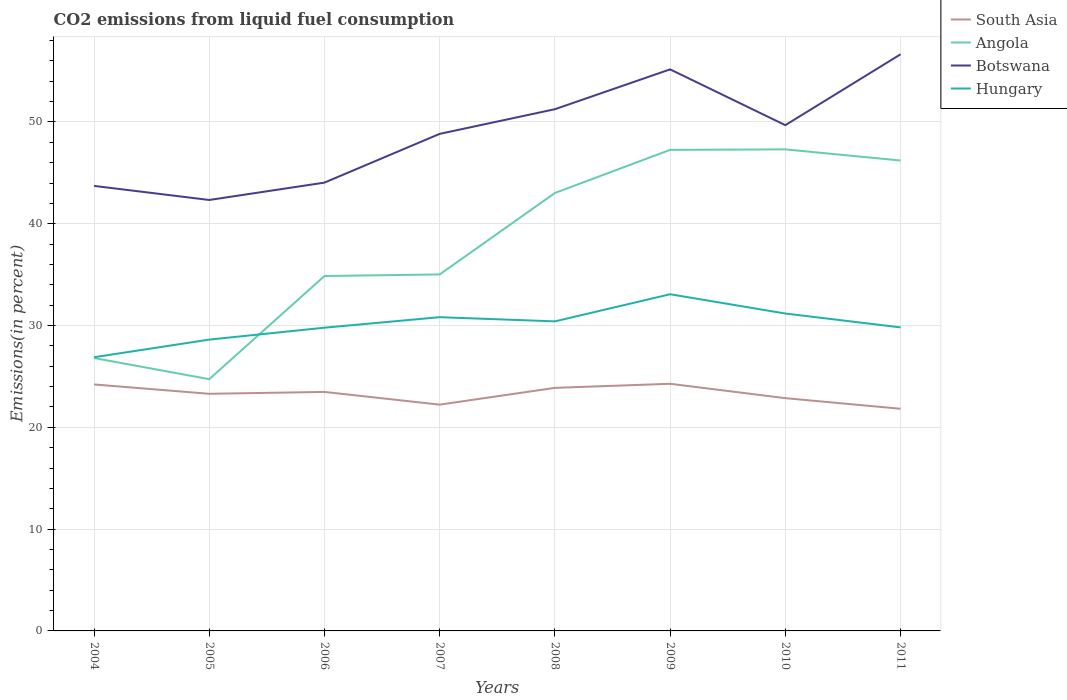How many different coloured lines are there?
Provide a succinct answer. 4. Across all years, what is the maximum total CO2 emitted in Angola?
Ensure brevity in your answer.  24.73. In which year was the total CO2 emitted in Angola maximum?
Keep it short and to the point. 2005. What is the total total CO2 emitted in South Asia in the graph?
Your response must be concise. -0.18. What is the difference between the highest and the second highest total CO2 emitted in South Asia?
Provide a short and direct response. 2.45. What is the difference between the highest and the lowest total CO2 emitted in Angola?
Offer a terse response. 4. How many lines are there?
Provide a short and direct response. 4. How many years are there in the graph?
Your response must be concise. 8. What is the difference between two consecutive major ticks on the Y-axis?
Provide a short and direct response. 10. Does the graph contain grids?
Keep it short and to the point. Yes. How are the legend labels stacked?
Provide a short and direct response. Vertical. What is the title of the graph?
Ensure brevity in your answer.  CO2 emissions from liquid fuel consumption. Does "Guam" appear as one of the legend labels in the graph?
Provide a succinct answer. No. What is the label or title of the X-axis?
Offer a very short reply. Years. What is the label or title of the Y-axis?
Your response must be concise. Emissions(in percent). What is the Emissions(in percent) in South Asia in 2004?
Give a very brief answer. 24.21. What is the Emissions(in percent) of Angola in 2004?
Offer a terse response. 26.81. What is the Emissions(in percent) in Botswana in 2004?
Make the answer very short. 43.72. What is the Emissions(in percent) in Hungary in 2004?
Your response must be concise. 26.89. What is the Emissions(in percent) of South Asia in 2005?
Provide a short and direct response. 23.29. What is the Emissions(in percent) of Angola in 2005?
Make the answer very short. 24.73. What is the Emissions(in percent) in Botswana in 2005?
Offer a very short reply. 42.34. What is the Emissions(in percent) of Hungary in 2005?
Keep it short and to the point. 28.62. What is the Emissions(in percent) in South Asia in 2006?
Keep it short and to the point. 23.48. What is the Emissions(in percent) of Angola in 2006?
Give a very brief answer. 34.86. What is the Emissions(in percent) in Botswana in 2006?
Provide a succinct answer. 44.04. What is the Emissions(in percent) in Hungary in 2006?
Your answer should be compact. 29.79. What is the Emissions(in percent) of South Asia in 2007?
Your answer should be very brief. 22.23. What is the Emissions(in percent) of Angola in 2007?
Offer a terse response. 35.02. What is the Emissions(in percent) of Botswana in 2007?
Your answer should be compact. 48.83. What is the Emissions(in percent) in Hungary in 2007?
Give a very brief answer. 30.82. What is the Emissions(in percent) of South Asia in 2008?
Offer a terse response. 23.88. What is the Emissions(in percent) of Angola in 2008?
Give a very brief answer. 43.02. What is the Emissions(in percent) in Botswana in 2008?
Offer a terse response. 51.25. What is the Emissions(in percent) in Hungary in 2008?
Ensure brevity in your answer.  30.41. What is the Emissions(in percent) of South Asia in 2009?
Offer a very short reply. 24.28. What is the Emissions(in percent) in Angola in 2009?
Offer a terse response. 47.26. What is the Emissions(in percent) of Botswana in 2009?
Your answer should be very brief. 55.17. What is the Emissions(in percent) of Hungary in 2009?
Your answer should be compact. 33.08. What is the Emissions(in percent) of South Asia in 2010?
Your answer should be very brief. 22.87. What is the Emissions(in percent) in Angola in 2010?
Keep it short and to the point. 47.31. What is the Emissions(in percent) of Botswana in 2010?
Offer a very short reply. 49.68. What is the Emissions(in percent) of Hungary in 2010?
Ensure brevity in your answer.  31.18. What is the Emissions(in percent) of South Asia in 2011?
Keep it short and to the point. 21.82. What is the Emissions(in percent) of Angola in 2011?
Ensure brevity in your answer.  46.21. What is the Emissions(in percent) of Botswana in 2011?
Your answer should be compact. 56.65. What is the Emissions(in percent) in Hungary in 2011?
Your answer should be very brief. 29.82. Across all years, what is the maximum Emissions(in percent) of South Asia?
Offer a terse response. 24.28. Across all years, what is the maximum Emissions(in percent) of Angola?
Offer a very short reply. 47.31. Across all years, what is the maximum Emissions(in percent) of Botswana?
Offer a very short reply. 56.65. Across all years, what is the maximum Emissions(in percent) of Hungary?
Provide a short and direct response. 33.08. Across all years, what is the minimum Emissions(in percent) of South Asia?
Provide a short and direct response. 21.82. Across all years, what is the minimum Emissions(in percent) of Angola?
Make the answer very short. 24.73. Across all years, what is the minimum Emissions(in percent) in Botswana?
Make the answer very short. 42.34. Across all years, what is the minimum Emissions(in percent) of Hungary?
Make the answer very short. 26.89. What is the total Emissions(in percent) in South Asia in the graph?
Offer a very short reply. 186.06. What is the total Emissions(in percent) in Angola in the graph?
Offer a very short reply. 305.22. What is the total Emissions(in percent) of Botswana in the graph?
Offer a terse response. 391.67. What is the total Emissions(in percent) in Hungary in the graph?
Give a very brief answer. 240.6. What is the difference between the Emissions(in percent) of South Asia in 2004 and that in 2005?
Keep it short and to the point. 0.92. What is the difference between the Emissions(in percent) of Angola in 2004 and that in 2005?
Your response must be concise. 2.08. What is the difference between the Emissions(in percent) in Botswana in 2004 and that in 2005?
Provide a succinct answer. 1.38. What is the difference between the Emissions(in percent) of Hungary in 2004 and that in 2005?
Offer a terse response. -1.73. What is the difference between the Emissions(in percent) of South Asia in 2004 and that in 2006?
Your answer should be very brief. 0.73. What is the difference between the Emissions(in percent) in Angola in 2004 and that in 2006?
Make the answer very short. -8.06. What is the difference between the Emissions(in percent) of Botswana in 2004 and that in 2006?
Offer a terse response. -0.32. What is the difference between the Emissions(in percent) in Hungary in 2004 and that in 2006?
Offer a terse response. -2.9. What is the difference between the Emissions(in percent) in South Asia in 2004 and that in 2007?
Provide a succinct answer. 1.98. What is the difference between the Emissions(in percent) in Angola in 2004 and that in 2007?
Your answer should be compact. -8.21. What is the difference between the Emissions(in percent) in Botswana in 2004 and that in 2007?
Give a very brief answer. -5.11. What is the difference between the Emissions(in percent) of Hungary in 2004 and that in 2007?
Your response must be concise. -3.94. What is the difference between the Emissions(in percent) of South Asia in 2004 and that in 2008?
Your answer should be very brief. 0.34. What is the difference between the Emissions(in percent) of Angola in 2004 and that in 2008?
Your answer should be very brief. -16.21. What is the difference between the Emissions(in percent) in Botswana in 2004 and that in 2008?
Provide a short and direct response. -7.53. What is the difference between the Emissions(in percent) of Hungary in 2004 and that in 2008?
Give a very brief answer. -3.52. What is the difference between the Emissions(in percent) of South Asia in 2004 and that in 2009?
Provide a succinct answer. -0.07. What is the difference between the Emissions(in percent) in Angola in 2004 and that in 2009?
Your answer should be very brief. -20.45. What is the difference between the Emissions(in percent) in Botswana in 2004 and that in 2009?
Keep it short and to the point. -11.45. What is the difference between the Emissions(in percent) in Hungary in 2004 and that in 2009?
Provide a succinct answer. -6.19. What is the difference between the Emissions(in percent) in South Asia in 2004 and that in 2010?
Offer a very short reply. 1.35. What is the difference between the Emissions(in percent) of Angola in 2004 and that in 2010?
Keep it short and to the point. -20.5. What is the difference between the Emissions(in percent) of Botswana in 2004 and that in 2010?
Give a very brief answer. -5.97. What is the difference between the Emissions(in percent) of Hungary in 2004 and that in 2010?
Your answer should be very brief. -4.29. What is the difference between the Emissions(in percent) in South Asia in 2004 and that in 2011?
Give a very brief answer. 2.39. What is the difference between the Emissions(in percent) in Angola in 2004 and that in 2011?
Offer a terse response. -19.4. What is the difference between the Emissions(in percent) in Botswana in 2004 and that in 2011?
Your answer should be very brief. -12.93. What is the difference between the Emissions(in percent) of Hungary in 2004 and that in 2011?
Your response must be concise. -2.93. What is the difference between the Emissions(in percent) in South Asia in 2005 and that in 2006?
Keep it short and to the point. -0.18. What is the difference between the Emissions(in percent) in Angola in 2005 and that in 2006?
Give a very brief answer. -10.13. What is the difference between the Emissions(in percent) of Botswana in 2005 and that in 2006?
Keep it short and to the point. -1.71. What is the difference between the Emissions(in percent) in Hungary in 2005 and that in 2006?
Provide a short and direct response. -1.17. What is the difference between the Emissions(in percent) in South Asia in 2005 and that in 2007?
Your response must be concise. 1.06. What is the difference between the Emissions(in percent) of Angola in 2005 and that in 2007?
Make the answer very short. -10.29. What is the difference between the Emissions(in percent) of Botswana in 2005 and that in 2007?
Offer a terse response. -6.49. What is the difference between the Emissions(in percent) in Hungary in 2005 and that in 2007?
Provide a short and direct response. -2.2. What is the difference between the Emissions(in percent) of South Asia in 2005 and that in 2008?
Offer a terse response. -0.58. What is the difference between the Emissions(in percent) of Angola in 2005 and that in 2008?
Provide a short and direct response. -18.29. What is the difference between the Emissions(in percent) in Botswana in 2005 and that in 2008?
Give a very brief answer. -8.92. What is the difference between the Emissions(in percent) in Hungary in 2005 and that in 2008?
Provide a short and direct response. -1.79. What is the difference between the Emissions(in percent) of South Asia in 2005 and that in 2009?
Your answer should be very brief. -0.98. What is the difference between the Emissions(in percent) in Angola in 2005 and that in 2009?
Provide a short and direct response. -22.53. What is the difference between the Emissions(in percent) in Botswana in 2005 and that in 2009?
Offer a terse response. -12.83. What is the difference between the Emissions(in percent) in Hungary in 2005 and that in 2009?
Your answer should be very brief. -4.46. What is the difference between the Emissions(in percent) in South Asia in 2005 and that in 2010?
Your answer should be compact. 0.43. What is the difference between the Emissions(in percent) in Angola in 2005 and that in 2010?
Offer a terse response. -22.57. What is the difference between the Emissions(in percent) in Botswana in 2005 and that in 2010?
Provide a short and direct response. -7.35. What is the difference between the Emissions(in percent) in Hungary in 2005 and that in 2010?
Ensure brevity in your answer.  -2.56. What is the difference between the Emissions(in percent) of South Asia in 2005 and that in 2011?
Your answer should be compact. 1.47. What is the difference between the Emissions(in percent) of Angola in 2005 and that in 2011?
Give a very brief answer. -21.48. What is the difference between the Emissions(in percent) in Botswana in 2005 and that in 2011?
Provide a succinct answer. -14.31. What is the difference between the Emissions(in percent) of Hungary in 2005 and that in 2011?
Provide a succinct answer. -1.2. What is the difference between the Emissions(in percent) of South Asia in 2006 and that in 2007?
Make the answer very short. 1.25. What is the difference between the Emissions(in percent) in Angola in 2006 and that in 2007?
Ensure brevity in your answer.  -0.15. What is the difference between the Emissions(in percent) of Botswana in 2006 and that in 2007?
Make the answer very short. -4.79. What is the difference between the Emissions(in percent) of Hungary in 2006 and that in 2007?
Make the answer very short. -1.03. What is the difference between the Emissions(in percent) of South Asia in 2006 and that in 2008?
Your response must be concise. -0.4. What is the difference between the Emissions(in percent) of Angola in 2006 and that in 2008?
Make the answer very short. -8.16. What is the difference between the Emissions(in percent) in Botswana in 2006 and that in 2008?
Keep it short and to the point. -7.21. What is the difference between the Emissions(in percent) in Hungary in 2006 and that in 2008?
Ensure brevity in your answer.  -0.62. What is the difference between the Emissions(in percent) of South Asia in 2006 and that in 2009?
Your answer should be compact. -0.8. What is the difference between the Emissions(in percent) in Angola in 2006 and that in 2009?
Offer a very short reply. -12.39. What is the difference between the Emissions(in percent) of Botswana in 2006 and that in 2009?
Ensure brevity in your answer.  -11.13. What is the difference between the Emissions(in percent) in Hungary in 2006 and that in 2009?
Offer a very short reply. -3.29. What is the difference between the Emissions(in percent) of South Asia in 2006 and that in 2010?
Keep it short and to the point. 0.61. What is the difference between the Emissions(in percent) in Angola in 2006 and that in 2010?
Your answer should be compact. -12.44. What is the difference between the Emissions(in percent) in Botswana in 2006 and that in 2010?
Make the answer very short. -5.64. What is the difference between the Emissions(in percent) in Hungary in 2006 and that in 2010?
Your answer should be very brief. -1.39. What is the difference between the Emissions(in percent) in South Asia in 2006 and that in 2011?
Keep it short and to the point. 1.65. What is the difference between the Emissions(in percent) of Angola in 2006 and that in 2011?
Make the answer very short. -11.35. What is the difference between the Emissions(in percent) of Botswana in 2006 and that in 2011?
Your answer should be very brief. -12.61. What is the difference between the Emissions(in percent) of Hungary in 2006 and that in 2011?
Your answer should be compact. -0.03. What is the difference between the Emissions(in percent) of South Asia in 2007 and that in 2008?
Provide a succinct answer. -1.65. What is the difference between the Emissions(in percent) in Angola in 2007 and that in 2008?
Offer a very short reply. -8. What is the difference between the Emissions(in percent) of Botswana in 2007 and that in 2008?
Provide a short and direct response. -2.42. What is the difference between the Emissions(in percent) in Hungary in 2007 and that in 2008?
Provide a short and direct response. 0.41. What is the difference between the Emissions(in percent) in South Asia in 2007 and that in 2009?
Provide a short and direct response. -2.05. What is the difference between the Emissions(in percent) of Angola in 2007 and that in 2009?
Ensure brevity in your answer.  -12.24. What is the difference between the Emissions(in percent) of Botswana in 2007 and that in 2009?
Make the answer very short. -6.34. What is the difference between the Emissions(in percent) of Hungary in 2007 and that in 2009?
Give a very brief answer. -2.25. What is the difference between the Emissions(in percent) of South Asia in 2007 and that in 2010?
Your response must be concise. -0.64. What is the difference between the Emissions(in percent) in Angola in 2007 and that in 2010?
Offer a terse response. -12.29. What is the difference between the Emissions(in percent) in Botswana in 2007 and that in 2010?
Your answer should be compact. -0.85. What is the difference between the Emissions(in percent) of Hungary in 2007 and that in 2010?
Make the answer very short. -0.36. What is the difference between the Emissions(in percent) of South Asia in 2007 and that in 2011?
Provide a short and direct response. 0.41. What is the difference between the Emissions(in percent) of Angola in 2007 and that in 2011?
Your answer should be compact. -11.19. What is the difference between the Emissions(in percent) in Botswana in 2007 and that in 2011?
Provide a short and direct response. -7.82. What is the difference between the Emissions(in percent) in Hungary in 2007 and that in 2011?
Give a very brief answer. 1.01. What is the difference between the Emissions(in percent) of South Asia in 2008 and that in 2009?
Your answer should be very brief. -0.4. What is the difference between the Emissions(in percent) of Angola in 2008 and that in 2009?
Offer a terse response. -4.24. What is the difference between the Emissions(in percent) in Botswana in 2008 and that in 2009?
Keep it short and to the point. -3.91. What is the difference between the Emissions(in percent) of Hungary in 2008 and that in 2009?
Ensure brevity in your answer.  -2.67. What is the difference between the Emissions(in percent) in South Asia in 2008 and that in 2010?
Provide a succinct answer. 1.01. What is the difference between the Emissions(in percent) in Angola in 2008 and that in 2010?
Your answer should be compact. -4.28. What is the difference between the Emissions(in percent) of Botswana in 2008 and that in 2010?
Your answer should be compact. 1.57. What is the difference between the Emissions(in percent) of Hungary in 2008 and that in 2010?
Your answer should be very brief. -0.77. What is the difference between the Emissions(in percent) in South Asia in 2008 and that in 2011?
Your answer should be very brief. 2.05. What is the difference between the Emissions(in percent) in Angola in 2008 and that in 2011?
Your response must be concise. -3.19. What is the difference between the Emissions(in percent) in Botswana in 2008 and that in 2011?
Ensure brevity in your answer.  -5.39. What is the difference between the Emissions(in percent) in Hungary in 2008 and that in 2011?
Provide a short and direct response. 0.59. What is the difference between the Emissions(in percent) of South Asia in 2009 and that in 2010?
Offer a terse response. 1.41. What is the difference between the Emissions(in percent) in Angola in 2009 and that in 2010?
Give a very brief answer. -0.05. What is the difference between the Emissions(in percent) in Botswana in 2009 and that in 2010?
Provide a succinct answer. 5.48. What is the difference between the Emissions(in percent) in Hungary in 2009 and that in 2010?
Make the answer very short. 1.9. What is the difference between the Emissions(in percent) of South Asia in 2009 and that in 2011?
Give a very brief answer. 2.45. What is the difference between the Emissions(in percent) of Angola in 2009 and that in 2011?
Keep it short and to the point. 1.05. What is the difference between the Emissions(in percent) in Botswana in 2009 and that in 2011?
Ensure brevity in your answer.  -1.48. What is the difference between the Emissions(in percent) in Hungary in 2009 and that in 2011?
Keep it short and to the point. 3.26. What is the difference between the Emissions(in percent) in South Asia in 2010 and that in 2011?
Offer a very short reply. 1.04. What is the difference between the Emissions(in percent) in Angola in 2010 and that in 2011?
Your answer should be very brief. 1.1. What is the difference between the Emissions(in percent) in Botswana in 2010 and that in 2011?
Ensure brevity in your answer.  -6.96. What is the difference between the Emissions(in percent) in Hungary in 2010 and that in 2011?
Offer a very short reply. 1.36. What is the difference between the Emissions(in percent) of South Asia in 2004 and the Emissions(in percent) of Angola in 2005?
Your answer should be very brief. -0.52. What is the difference between the Emissions(in percent) in South Asia in 2004 and the Emissions(in percent) in Botswana in 2005?
Give a very brief answer. -18.12. What is the difference between the Emissions(in percent) of South Asia in 2004 and the Emissions(in percent) of Hungary in 2005?
Provide a succinct answer. -4.41. What is the difference between the Emissions(in percent) in Angola in 2004 and the Emissions(in percent) in Botswana in 2005?
Give a very brief answer. -15.53. What is the difference between the Emissions(in percent) of Angola in 2004 and the Emissions(in percent) of Hungary in 2005?
Provide a short and direct response. -1.81. What is the difference between the Emissions(in percent) in Botswana in 2004 and the Emissions(in percent) in Hungary in 2005?
Offer a terse response. 15.1. What is the difference between the Emissions(in percent) of South Asia in 2004 and the Emissions(in percent) of Angola in 2006?
Offer a very short reply. -10.65. What is the difference between the Emissions(in percent) in South Asia in 2004 and the Emissions(in percent) in Botswana in 2006?
Make the answer very short. -19.83. What is the difference between the Emissions(in percent) of South Asia in 2004 and the Emissions(in percent) of Hungary in 2006?
Make the answer very short. -5.58. What is the difference between the Emissions(in percent) of Angola in 2004 and the Emissions(in percent) of Botswana in 2006?
Make the answer very short. -17.23. What is the difference between the Emissions(in percent) in Angola in 2004 and the Emissions(in percent) in Hungary in 2006?
Give a very brief answer. -2.98. What is the difference between the Emissions(in percent) in Botswana in 2004 and the Emissions(in percent) in Hungary in 2006?
Offer a very short reply. 13.93. What is the difference between the Emissions(in percent) of South Asia in 2004 and the Emissions(in percent) of Angola in 2007?
Provide a succinct answer. -10.81. What is the difference between the Emissions(in percent) of South Asia in 2004 and the Emissions(in percent) of Botswana in 2007?
Offer a very short reply. -24.62. What is the difference between the Emissions(in percent) of South Asia in 2004 and the Emissions(in percent) of Hungary in 2007?
Provide a succinct answer. -6.61. What is the difference between the Emissions(in percent) in Angola in 2004 and the Emissions(in percent) in Botswana in 2007?
Ensure brevity in your answer.  -22.02. What is the difference between the Emissions(in percent) of Angola in 2004 and the Emissions(in percent) of Hungary in 2007?
Provide a short and direct response. -4.01. What is the difference between the Emissions(in percent) in Botswana in 2004 and the Emissions(in percent) in Hungary in 2007?
Ensure brevity in your answer.  12.9. What is the difference between the Emissions(in percent) of South Asia in 2004 and the Emissions(in percent) of Angola in 2008?
Give a very brief answer. -18.81. What is the difference between the Emissions(in percent) of South Asia in 2004 and the Emissions(in percent) of Botswana in 2008?
Your answer should be compact. -27.04. What is the difference between the Emissions(in percent) of South Asia in 2004 and the Emissions(in percent) of Hungary in 2008?
Keep it short and to the point. -6.2. What is the difference between the Emissions(in percent) in Angola in 2004 and the Emissions(in percent) in Botswana in 2008?
Keep it short and to the point. -24.44. What is the difference between the Emissions(in percent) in Angola in 2004 and the Emissions(in percent) in Hungary in 2008?
Ensure brevity in your answer.  -3.6. What is the difference between the Emissions(in percent) in Botswana in 2004 and the Emissions(in percent) in Hungary in 2008?
Your answer should be compact. 13.31. What is the difference between the Emissions(in percent) of South Asia in 2004 and the Emissions(in percent) of Angola in 2009?
Keep it short and to the point. -23.05. What is the difference between the Emissions(in percent) of South Asia in 2004 and the Emissions(in percent) of Botswana in 2009?
Your answer should be very brief. -30.95. What is the difference between the Emissions(in percent) in South Asia in 2004 and the Emissions(in percent) in Hungary in 2009?
Your answer should be very brief. -8.86. What is the difference between the Emissions(in percent) in Angola in 2004 and the Emissions(in percent) in Botswana in 2009?
Give a very brief answer. -28.36. What is the difference between the Emissions(in percent) of Angola in 2004 and the Emissions(in percent) of Hungary in 2009?
Provide a succinct answer. -6.27. What is the difference between the Emissions(in percent) in Botswana in 2004 and the Emissions(in percent) in Hungary in 2009?
Your response must be concise. 10.64. What is the difference between the Emissions(in percent) in South Asia in 2004 and the Emissions(in percent) in Angola in 2010?
Offer a very short reply. -23.09. What is the difference between the Emissions(in percent) in South Asia in 2004 and the Emissions(in percent) in Botswana in 2010?
Give a very brief answer. -25.47. What is the difference between the Emissions(in percent) of South Asia in 2004 and the Emissions(in percent) of Hungary in 2010?
Offer a terse response. -6.97. What is the difference between the Emissions(in percent) in Angola in 2004 and the Emissions(in percent) in Botswana in 2010?
Give a very brief answer. -22.87. What is the difference between the Emissions(in percent) in Angola in 2004 and the Emissions(in percent) in Hungary in 2010?
Provide a short and direct response. -4.37. What is the difference between the Emissions(in percent) in Botswana in 2004 and the Emissions(in percent) in Hungary in 2010?
Provide a succinct answer. 12.54. What is the difference between the Emissions(in percent) in South Asia in 2004 and the Emissions(in percent) in Angola in 2011?
Give a very brief answer. -22. What is the difference between the Emissions(in percent) of South Asia in 2004 and the Emissions(in percent) of Botswana in 2011?
Offer a terse response. -32.43. What is the difference between the Emissions(in percent) in South Asia in 2004 and the Emissions(in percent) in Hungary in 2011?
Your answer should be very brief. -5.6. What is the difference between the Emissions(in percent) in Angola in 2004 and the Emissions(in percent) in Botswana in 2011?
Your response must be concise. -29.84. What is the difference between the Emissions(in percent) in Angola in 2004 and the Emissions(in percent) in Hungary in 2011?
Offer a very short reply. -3.01. What is the difference between the Emissions(in percent) in Botswana in 2004 and the Emissions(in percent) in Hungary in 2011?
Give a very brief answer. 13.9. What is the difference between the Emissions(in percent) of South Asia in 2005 and the Emissions(in percent) of Angola in 2006?
Your response must be concise. -11.57. What is the difference between the Emissions(in percent) of South Asia in 2005 and the Emissions(in percent) of Botswana in 2006?
Make the answer very short. -20.75. What is the difference between the Emissions(in percent) in South Asia in 2005 and the Emissions(in percent) in Hungary in 2006?
Ensure brevity in your answer.  -6.49. What is the difference between the Emissions(in percent) in Angola in 2005 and the Emissions(in percent) in Botswana in 2006?
Provide a short and direct response. -19.31. What is the difference between the Emissions(in percent) of Angola in 2005 and the Emissions(in percent) of Hungary in 2006?
Keep it short and to the point. -5.06. What is the difference between the Emissions(in percent) of Botswana in 2005 and the Emissions(in percent) of Hungary in 2006?
Ensure brevity in your answer.  12.55. What is the difference between the Emissions(in percent) of South Asia in 2005 and the Emissions(in percent) of Angola in 2007?
Your response must be concise. -11.73. What is the difference between the Emissions(in percent) of South Asia in 2005 and the Emissions(in percent) of Botswana in 2007?
Provide a short and direct response. -25.54. What is the difference between the Emissions(in percent) of South Asia in 2005 and the Emissions(in percent) of Hungary in 2007?
Provide a short and direct response. -7.53. What is the difference between the Emissions(in percent) in Angola in 2005 and the Emissions(in percent) in Botswana in 2007?
Offer a terse response. -24.1. What is the difference between the Emissions(in percent) in Angola in 2005 and the Emissions(in percent) in Hungary in 2007?
Your response must be concise. -6.09. What is the difference between the Emissions(in percent) of Botswana in 2005 and the Emissions(in percent) of Hungary in 2007?
Provide a succinct answer. 11.51. What is the difference between the Emissions(in percent) of South Asia in 2005 and the Emissions(in percent) of Angola in 2008?
Offer a very short reply. -19.73. What is the difference between the Emissions(in percent) of South Asia in 2005 and the Emissions(in percent) of Botswana in 2008?
Offer a very short reply. -27.96. What is the difference between the Emissions(in percent) of South Asia in 2005 and the Emissions(in percent) of Hungary in 2008?
Your response must be concise. -7.12. What is the difference between the Emissions(in percent) in Angola in 2005 and the Emissions(in percent) in Botswana in 2008?
Offer a terse response. -26.52. What is the difference between the Emissions(in percent) of Angola in 2005 and the Emissions(in percent) of Hungary in 2008?
Provide a succinct answer. -5.68. What is the difference between the Emissions(in percent) in Botswana in 2005 and the Emissions(in percent) in Hungary in 2008?
Ensure brevity in your answer.  11.93. What is the difference between the Emissions(in percent) of South Asia in 2005 and the Emissions(in percent) of Angola in 2009?
Give a very brief answer. -23.96. What is the difference between the Emissions(in percent) of South Asia in 2005 and the Emissions(in percent) of Botswana in 2009?
Ensure brevity in your answer.  -31.87. What is the difference between the Emissions(in percent) of South Asia in 2005 and the Emissions(in percent) of Hungary in 2009?
Make the answer very short. -9.78. What is the difference between the Emissions(in percent) of Angola in 2005 and the Emissions(in percent) of Botswana in 2009?
Provide a short and direct response. -30.43. What is the difference between the Emissions(in percent) of Angola in 2005 and the Emissions(in percent) of Hungary in 2009?
Offer a terse response. -8.34. What is the difference between the Emissions(in percent) of Botswana in 2005 and the Emissions(in percent) of Hungary in 2009?
Offer a very short reply. 9.26. What is the difference between the Emissions(in percent) of South Asia in 2005 and the Emissions(in percent) of Angola in 2010?
Keep it short and to the point. -24.01. What is the difference between the Emissions(in percent) of South Asia in 2005 and the Emissions(in percent) of Botswana in 2010?
Your response must be concise. -26.39. What is the difference between the Emissions(in percent) of South Asia in 2005 and the Emissions(in percent) of Hungary in 2010?
Provide a short and direct response. -7.89. What is the difference between the Emissions(in percent) in Angola in 2005 and the Emissions(in percent) in Botswana in 2010?
Your response must be concise. -24.95. What is the difference between the Emissions(in percent) of Angola in 2005 and the Emissions(in percent) of Hungary in 2010?
Give a very brief answer. -6.45. What is the difference between the Emissions(in percent) of Botswana in 2005 and the Emissions(in percent) of Hungary in 2010?
Your response must be concise. 11.16. What is the difference between the Emissions(in percent) in South Asia in 2005 and the Emissions(in percent) in Angola in 2011?
Your answer should be compact. -22.92. What is the difference between the Emissions(in percent) of South Asia in 2005 and the Emissions(in percent) of Botswana in 2011?
Your response must be concise. -33.35. What is the difference between the Emissions(in percent) of South Asia in 2005 and the Emissions(in percent) of Hungary in 2011?
Provide a short and direct response. -6.52. What is the difference between the Emissions(in percent) in Angola in 2005 and the Emissions(in percent) in Botswana in 2011?
Make the answer very short. -31.91. What is the difference between the Emissions(in percent) in Angola in 2005 and the Emissions(in percent) in Hungary in 2011?
Provide a succinct answer. -5.08. What is the difference between the Emissions(in percent) of Botswana in 2005 and the Emissions(in percent) of Hungary in 2011?
Your answer should be compact. 12.52. What is the difference between the Emissions(in percent) in South Asia in 2006 and the Emissions(in percent) in Angola in 2007?
Your response must be concise. -11.54. What is the difference between the Emissions(in percent) of South Asia in 2006 and the Emissions(in percent) of Botswana in 2007?
Your answer should be very brief. -25.35. What is the difference between the Emissions(in percent) in South Asia in 2006 and the Emissions(in percent) in Hungary in 2007?
Offer a terse response. -7.34. What is the difference between the Emissions(in percent) in Angola in 2006 and the Emissions(in percent) in Botswana in 2007?
Your answer should be very brief. -13.96. What is the difference between the Emissions(in percent) in Angola in 2006 and the Emissions(in percent) in Hungary in 2007?
Give a very brief answer. 4.04. What is the difference between the Emissions(in percent) in Botswana in 2006 and the Emissions(in percent) in Hungary in 2007?
Provide a short and direct response. 13.22. What is the difference between the Emissions(in percent) in South Asia in 2006 and the Emissions(in percent) in Angola in 2008?
Make the answer very short. -19.54. What is the difference between the Emissions(in percent) in South Asia in 2006 and the Emissions(in percent) in Botswana in 2008?
Your answer should be compact. -27.77. What is the difference between the Emissions(in percent) in South Asia in 2006 and the Emissions(in percent) in Hungary in 2008?
Your answer should be compact. -6.93. What is the difference between the Emissions(in percent) in Angola in 2006 and the Emissions(in percent) in Botswana in 2008?
Give a very brief answer. -16.39. What is the difference between the Emissions(in percent) in Angola in 2006 and the Emissions(in percent) in Hungary in 2008?
Provide a succinct answer. 4.46. What is the difference between the Emissions(in percent) of Botswana in 2006 and the Emissions(in percent) of Hungary in 2008?
Give a very brief answer. 13.63. What is the difference between the Emissions(in percent) of South Asia in 2006 and the Emissions(in percent) of Angola in 2009?
Ensure brevity in your answer.  -23.78. What is the difference between the Emissions(in percent) of South Asia in 2006 and the Emissions(in percent) of Botswana in 2009?
Offer a very short reply. -31.69. What is the difference between the Emissions(in percent) in South Asia in 2006 and the Emissions(in percent) in Hungary in 2009?
Make the answer very short. -9.6. What is the difference between the Emissions(in percent) of Angola in 2006 and the Emissions(in percent) of Botswana in 2009?
Your answer should be compact. -20.3. What is the difference between the Emissions(in percent) in Angola in 2006 and the Emissions(in percent) in Hungary in 2009?
Your answer should be compact. 1.79. What is the difference between the Emissions(in percent) of Botswana in 2006 and the Emissions(in percent) of Hungary in 2009?
Keep it short and to the point. 10.97. What is the difference between the Emissions(in percent) in South Asia in 2006 and the Emissions(in percent) in Angola in 2010?
Keep it short and to the point. -23.83. What is the difference between the Emissions(in percent) in South Asia in 2006 and the Emissions(in percent) in Botswana in 2010?
Keep it short and to the point. -26.21. What is the difference between the Emissions(in percent) in South Asia in 2006 and the Emissions(in percent) in Hungary in 2010?
Provide a short and direct response. -7.7. What is the difference between the Emissions(in percent) in Angola in 2006 and the Emissions(in percent) in Botswana in 2010?
Give a very brief answer. -14.82. What is the difference between the Emissions(in percent) of Angola in 2006 and the Emissions(in percent) of Hungary in 2010?
Make the answer very short. 3.69. What is the difference between the Emissions(in percent) of Botswana in 2006 and the Emissions(in percent) of Hungary in 2010?
Offer a terse response. 12.86. What is the difference between the Emissions(in percent) in South Asia in 2006 and the Emissions(in percent) in Angola in 2011?
Your answer should be very brief. -22.73. What is the difference between the Emissions(in percent) of South Asia in 2006 and the Emissions(in percent) of Botswana in 2011?
Ensure brevity in your answer.  -33.17. What is the difference between the Emissions(in percent) in South Asia in 2006 and the Emissions(in percent) in Hungary in 2011?
Provide a short and direct response. -6.34. What is the difference between the Emissions(in percent) in Angola in 2006 and the Emissions(in percent) in Botswana in 2011?
Your response must be concise. -21.78. What is the difference between the Emissions(in percent) of Angola in 2006 and the Emissions(in percent) of Hungary in 2011?
Provide a succinct answer. 5.05. What is the difference between the Emissions(in percent) in Botswana in 2006 and the Emissions(in percent) in Hungary in 2011?
Your response must be concise. 14.22. What is the difference between the Emissions(in percent) of South Asia in 2007 and the Emissions(in percent) of Angola in 2008?
Make the answer very short. -20.79. What is the difference between the Emissions(in percent) of South Asia in 2007 and the Emissions(in percent) of Botswana in 2008?
Your answer should be compact. -29.02. What is the difference between the Emissions(in percent) in South Asia in 2007 and the Emissions(in percent) in Hungary in 2008?
Your answer should be compact. -8.18. What is the difference between the Emissions(in percent) in Angola in 2007 and the Emissions(in percent) in Botswana in 2008?
Provide a succinct answer. -16.23. What is the difference between the Emissions(in percent) of Angola in 2007 and the Emissions(in percent) of Hungary in 2008?
Your answer should be very brief. 4.61. What is the difference between the Emissions(in percent) in Botswana in 2007 and the Emissions(in percent) in Hungary in 2008?
Provide a short and direct response. 18.42. What is the difference between the Emissions(in percent) of South Asia in 2007 and the Emissions(in percent) of Angola in 2009?
Keep it short and to the point. -25.03. What is the difference between the Emissions(in percent) of South Asia in 2007 and the Emissions(in percent) of Botswana in 2009?
Keep it short and to the point. -32.94. What is the difference between the Emissions(in percent) of South Asia in 2007 and the Emissions(in percent) of Hungary in 2009?
Make the answer very short. -10.84. What is the difference between the Emissions(in percent) in Angola in 2007 and the Emissions(in percent) in Botswana in 2009?
Provide a succinct answer. -20.15. What is the difference between the Emissions(in percent) of Angola in 2007 and the Emissions(in percent) of Hungary in 2009?
Offer a very short reply. 1.94. What is the difference between the Emissions(in percent) of Botswana in 2007 and the Emissions(in percent) of Hungary in 2009?
Ensure brevity in your answer.  15.75. What is the difference between the Emissions(in percent) in South Asia in 2007 and the Emissions(in percent) in Angola in 2010?
Offer a terse response. -25.08. What is the difference between the Emissions(in percent) in South Asia in 2007 and the Emissions(in percent) in Botswana in 2010?
Make the answer very short. -27.45. What is the difference between the Emissions(in percent) of South Asia in 2007 and the Emissions(in percent) of Hungary in 2010?
Offer a very short reply. -8.95. What is the difference between the Emissions(in percent) in Angola in 2007 and the Emissions(in percent) in Botswana in 2010?
Your answer should be compact. -14.66. What is the difference between the Emissions(in percent) in Angola in 2007 and the Emissions(in percent) in Hungary in 2010?
Your answer should be compact. 3.84. What is the difference between the Emissions(in percent) in Botswana in 2007 and the Emissions(in percent) in Hungary in 2010?
Keep it short and to the point. 17.65. What is the difference between the Emissions(in percent) in South Asia in 2007 and the Emissions(in percent) in Angola in 2011?
Provide a short and direct response. -23.98. What is the difference between the Emissions(in percent) of South Asia in 2007 and the Emissions(in percent) of Botswana in 2011?
Your response must be concise. -34.42. What is the difference between the Emissions(in percent) of South Asia in 2007 and the Emissions(in percent) of Hungary in 2011?
Make the answer very short. -7.59. What is the difference between the Emissions(in percent) of Angola in 2007 and the Emissions(in percent) of Botswana in 2011?
Keep it short and to the point. -21.63. What is the difference between the Emissions(in percent) in Angola in 2007 and the Emissions(in percent) in Hungary in 2011?
Ensure brevity in your answer.  5.2. What is the difference between the Emissions(in percent) in Botswana in 2007 and the Emissions(in percent) in Hungary in 2011?
Make the answer very short. 19.01. What is the difference between the Emissions(in percent) of South Asia in 2008 and the Emissions(in percent) of Angola in 2009?
Your response must be concise. -23.38. What is the difference between the Emissions(in percent) in South Asia in 2008 and the Emissions(in percent) in Botswana in 2009?
Your answer should be very brief. -31.29. What is the difference between the Emissions(in percent) in South Asia in 2008 and the Emissions(in percent) in Hungary in 2009?
Your response must be concise. -9.2. What is the difference between the Emissions(in percent) in Angola in 2008 and the Emissions(in percent) in Botswana in 2009?
Offer a very short reply. -12.14. What is the difference between the Emissions(in percent) of Angola in 2008 and the Emissions(in percent) of Hungary in 2009?
Your answer should be very brief. 9.95. What is the difference between the Emissions(in percent) of Botswana in 2008 and the Emissions(in percent) of Hungary in 2009?
Offer a terse response. 18.18. What is the difference between the Emissions(in percent) in South Asia in 2008 and the Emissions(in percent) in Angola in 2010?
Give a very brief answer. -23.43. What is the difference between the Emissions(in percent) in South Asia in 2008 and the Emissions(in percent) in Botswana in 2010?
Your answer should be compact. -25.81. What is the difference between the Emissions(in percent) of South Asia in 2008 and the Emissions(in percent) of Hungary in 2010?
Keep it short and to the point. -7.3. What is the difference between the Emissions(in percent) in Angola in 2008 and the Emissions(in percent) in Botswana in 2010?
Offer a very short reply. -6.66. What is the difference between the Emissions(in percent) in Angola in 2008 and the Emissions(in percent) in Hungary in 2010?
Offer a terse response. 11.84. What is the difference between the Emissions(in percent) of Botswana in 2008 and the Emissions(in percent) of Hungary in 2010?
Offer a very short reply. 20.07. What is the difference between the Emissions(in percent) in South Asia in 2008 and the Emissions(in percent) in Angola in 2011?
Keep it short and to the point. -22.33. What is the difference between the Emissions(in percent) in South Asia in 2008 and the Emissions(in percent) in Botswana in 2011?
Keep it short and to the point. -32.77. What is the difference between the Emissions(in percent) in South Asia in 2008 and the Emissions(in percent) in Hungary in 2011?
Keep it short and to the point. -5.94. What is the difference between the Emissions(in percent) in Angola in 2008 and the Emissions(in percent) in Botswana in 2011?
Keep it short and to the point. -13.62. What is the difference between the Emissions(in percent) of Angola in 2008 and the Emissions(in percent) of Hungary in 2011?
Provide a succinct answer. 13.21. What is the difference between the Emissions(in percent) in Botswana in 2008 and the Emissions(in percent) in Hungary in 2011?
Offer a terse response. 21.43. What is the difference between the Emissions(in percent) in South Asia in 2009 and the Emissions(in percent) in Angola in 2010?
Make the answer very short. -23.03. What is the difference between the Emissions(in percent) of South Asia in 2009 and the Emissions(in percent) of Botswana in 2010?
Provide a short and direct response. -25.41. What is the difference between the Emissions(in percent) in South Asia in 2009 and the Emissions(in percent) in Hungary in 2010?
Offer a terse response. -6.9. What is the difference between the Emissions(in percent) of Angola in 2009 and the Emissions(in percent) of Botswana in 2010?
Your response must be concise. -2.43. What is the difference between the Emissions(in percent) of Angola in 2009 and the Emissions(in percent) of Hungary in 2010?
Offer a terse response. 16.08. What is the difference between the Emissions(in percent) of Botswana in 2009 and the Emissions(in percent) of Hungary in 2010?
Your response must be concise. 23.99. What is the difference between the Emissions(in percent) of South Asia in 2009 and the Emissions(in percent) of Angola in 2011?
Your answer should be compact. -21.93. What is the difference between the Emissions(in percent) in South Asia in 2009 and the Emissions(in percent) in Botswana in 2011?
Ensure brevity in your answer.  -32.37. What is the difference between the Emissions(in percent) in South Asia in 2009 and the Emissions(in percent) in Hungary in 2011?
Provide a succinct answer. -5.54. What is the difference between the Emissions(in percent) of Angola in 2009 and the Emissions(in percent) of Botswana in 2011?
Make the answer very short. -9.39. What is the difference between the Emissions(in percent) of Angola in 2009 and the Emissions(in percent) of Hungary in 2011?
Give a very brief answer. 17.44. What is the difference between the Emissions(in percent) in Botswana in 2009 and the Emissions(in percent) in Hungary in 2011?
Provide a short and direct response. 25.35. What is the difference between the Emissions(in percent) of South Asia in 2010 and the Emissions(in percent) of Angola in 2011?
Provide a short and direct response. -23.35. What is the difference between the Emissions(in percent) of South Asia in 2010 and the Emissions(in percent) of Botswana in 2011?
Keep it short and to the point. -33.78. What is the difference between the Emissions(in percent) of South Asia in 2010 and the Emissions(in percent) of Hungary in 2011?
Your answer should be very brief. -6.95. What is the difference between the Emissions(in percent) in Angola in 2010 and the Emissions(in percent) in Botswana in 2011?
Your response must be concise. -9.34. What is the difference between the Emissions(in percent) of Angola in 2010 and the Emissions(in percent) of Hungary in 2011?
Your answer should be very brief. 17.49. What is the difference between the Emissions(in percent) of Botswana in 2010 and the Emissions(in percent) of Hungary in 2011?
Keep it short and to the point. 19.87. What is the average Emissions(in percent) of South Asia per year?
Make the answer very short. 23.26. What is the average Emissions(in percent) in Angola per year?
Provide a short and direct response. 38.15. What is the average Emissions(in percent) in Botswana per year?
Your response must be concise. 48.96. What is the average Emissions(in percent) in Hungary per year?
Provide a short and direct response. 30.07. In the year 2004, what is the difference between the Emissions(in percent) in South Asia and Emissions(in percent) in Angola?
Keep it short and to the point. -2.6. In the year 2004, what is the difference between the Emissions(in percent) in South Asia and Emissions(in percent) in Botswana?
Offer a very short reply. -19.51. In the year 2004, what is the difference between the Emissions(in percent) of South Asia and Emissions(in percent) of Hungary?
Your answer should be compact. -2.67. In the year 2004, what is the difference between the Emissions(in percent) of Angola and Emissions(in percent) of Botswana?
Your response must be concise. -16.91. In the year 2004, what is the difference between the Emissions(in percent) of Angola and Emissions(in percent) of Hungary?
Provide a succinct answer. -0.08. In the year 2004, what is the difference between the Emissions(in percent) of Botswana and Emissions(in percent) of Hungary?
Make the answer very short. 16.83. In the year 2005, what is the difference between the Emissions(in percent) of South Asia and Emissions(in percent) of Angola?
Your answer should be very brief. -1.44. In the year 2005, what is the difference between the Emissions(in percent) in South Asia and Emissions(in percent) in Botswana?
Your answer should be compact. -19.04. In the year 2005, what is the difference between the Emissions(in percent) of South Asia and Emissions(in percent) of Hungary?
Ensure brevity in your answer.  -5.32. In the year 2005, what is the difference between the Emissions(in percent) in Angola and Emissions(in percent) in Botswana?
Ensure brevity in your answer.  -17.6. In the year 2005, what is the difference between the Emissions(in percent) of Angola and Emissions(in percent) of Hungary?
Provide a short and direct response. -3.89. In the year 2005, what is the difference between the Emissions(in percent) of Botswana and Emissions(in percent) of Hungary?
Your answer should be compact. 13.72. In the year 2006, what is the difference between the Emissions(in percent) of South Asia and Emissions(in percent) of Angola?
Keep it short and to the point. -11.39. In the year 2006, what is the difference between the Emissions(in percent) in South Asia and Emissions(in percent) in Botswana?
Offer a terse response. -20.56. In the year 2006, what is the difference between the Emissions(in percent) of South Asia and Emissions(in percent) of Hungary?
Your answer should be very brief. -6.31. In the year 2006, what is the difference between the Emissions(in percent) in Angola and Emissions(in percent) in Botswana?
Offer a very short reply. -9.18. In the year 2006, what is the difference between the Emissions(in percent) in Angola and Emissions(in percent) in Hungary?
Provide a succinct answer. 5.08. In the year 2006, what is the difference between the Emissions(in percent) of Botswana and Emissions(in percent) of Hungary?
Your answer should be very brief. 14.25. In the year 2007, what is the difference between the Emissions(in percent) in South Asia and Emissions(in percent) in Angola?
Your answer should be compact. -12.79. In the year 2007, what is the difference between the Emissions(in percent) in South Asia and Emissions(in percent) in Botswana?
Provide a short and direct response. -26.6. In the year 2007, what is the difference between the Emissions(in percent) in South Asia and Emissions(in percent) in Hungary?
Your answer should be compact. -8.59. In the year 2007, what is the difference between the Emissions(in percent) of Angola and Emissions(in percent) of Botswana?
Ensure brevity in your answer.  -13.81. In the year 2007, what is the difference between the Emissions(in percent) of Angola and Emissions(in percent) of Hungary?
Make the answer very short. 4.2. In the year 2007, what is the difference between the Emissions(in percent) of Botswana and Emissions(in percent) of Hungary?
Your response must be concise. 18.01. In the year 2008, what is the difference between the Emissions(in percent) of South Asia and Emissions(in percent) of Angola?
Make the answer very short. -19.15. In the year 2008, what is the difference between the Emissions(in percent) of South Asia and Emissions(in percent) of Botswana?
Give a very brief answer. -27.37. In the year 2008, what is the difference between the Emissions(in percent) of South Asia and Emissions(in percent) of Hungary?
Keep it short and to the point. -6.53. In the year 2008, what is the difference between the Emissions(in percent) in Angola and Emissions(in percent) in Botswana?
Your answer should be compact. -8.23. In the year 2008, what is the difference between the Emissions(in percent) in Angola and Emissions(in percent) in Hungary?
Your response must be concise. 12.61. In the year 2008, what is the difference between the Emissions(in percent) of Botswana and Emissions(in percent) of Hungary?
Offer a very short reply. 20.84. In the year 2009, what is the difference between the Emissions(in percent) in South Asia and Emissions(in percent) in Angola?
Your response must be concise. -22.98. In the year 2009, what is the difference between the Emissions(in percent) in South Asia and Emissions(in percent) in Botswana?
Offer a very short reply. -30.89. In the year 2009, what is the difference between the Emissions(in percent) of South Asia and Emissions(in percent) of Hungary?
Provide a short and direct response. -8.8. In the year 2009, what is the difference between the Emissions(in percent) in Angola and Emissions(in percent) in Botswana?
Provide a succinct answer. -7.91. In the year 2009, what is the difference between the Emissions(in percent) of Angola and Emissions(in percent) of Hungary?
Make the answer very short. 14.18. In the year 2009, what is the difference between the Emissions(in percent) of Botswana and Emissions(in percent) of Hungary?
Provide a succinct answer. 22.09. In the year 2010, what is the difference between the Emissions(in percent) in South Asia and Emissions(in percent) in Angola?
Give a very brief answer. -24.44. In the year 2010, what is the difference between the Emissions(in percent) in South Asia and Emissions(in percent) in Botswana?
Your response must be concise. -26.82. In the year 2010, what is the difference between the Emissions(in percent) in South Asia and Emissions(in percent) in Hungary?
Provide a succinct answer. -8.31. In the year 2010, what is the difference between the Emissions(in percent) in Angola and Emissions(in percent) in Botswana?
Your answer should be compact. -2.38. In the year 2010, what is the difference between the Emissions(in percent) in Angola and Emissions(in percent) in Hungary?
Your response must be concise. 16.13. In the year 2010, what is the difference between the Emissions(in percent) in Botswana and Emissions(in percent) in Hungary?
Your answer should be very brief. 18.5. In the year 2011, what is the difference between the Emissions(in percent) in South Asia and Emissions(in percent) in Angola?
Give a very brief answer. -24.39. In the year 2011, what is the difference between the Emissions(in percent) in South Asia and Emissions(in percent) in Botswana?
Your response must be concise. -34.82. In the year 2011, what is the difference between the Emissions(in percent) in South Asia and Emissions(in percent) in Hungary?
Your response must be concise. -7.99. In the year 2011, what is the difference between the Emissions(in percent) of Angola and Emissions(in percent) of Botswana?
Your answer should be compact. -10.44. In the year 2011, what is the difference between the Emissions(in percent) in Angola and Emissions(in percent) in Hungary?
Your answer should be very brief. 16.39. In the year 2011, what is the difference between the Emissions(in percent) in Botswana and Emissions(in percent) in Hungary?
Your answer should be very brief. 26.83. What is the ratio of the Emissions(in percent) of South Asia in 2004 to that in 2005?
Offer a terse response. 1.04. What is the ratio of the Emissions(in percent) of Angola in 2004 to that in 2005?
Make the answer very short. 1.08. What is the ratio of the Emissions(in percent) of Botswana in 2004 to that in 2005?
Offer a very short reply. 1.03. What is the ratio of the Emissions(in percent) in Hungary in 2004 to that in 2005?
Provide a succinct answer. 0.94. What is the ratio of the Emissions(in percent) of South Asia in 2004 to that in 2006?
Keep it short and to the point. 1.03. What is the ratio of the Emissions(in percent) in Angola in 2004 to that in 2006?
Keep it short and to the point. 0.77. What is the ratio of the Emissions(in percent) of Botswana in 2004 to that in 2006?
Keep it short and to the point. 0.99. What is the ratio of the Emissions(in percent) of Hungary in 2004 to that in 2006?
Your answer should be very brief. 0.9. What is the ratio of the Emissions(in percent) in South Asia in 2004 to that in 2007?
Make the answer very short. 1.09. What is the ratio of the Emissions(in percent) in Angola in 2004 to that in 2007?
Provide a short and direct response. 0.77. What is the ratio of the Emissions(in percent) of Botswana in 2004 to that in 2007?
Your answer should be very brief. 0.9. What is the ratio of the Emissions(in percent) of Hungary in 2004 to that in 2007?
Offer a terse response. 0.87. What is the ratio of the Emissions(in percent) of South Asia in 2004 to that in 2008?
Provide a short and direct response. 1.01. What is the ratio of the Emissions(in percent) of Angola in 2004 to that in 2008?
Give a very brief answer. 0.62. What is the ratio of the Emissions(in percent) in Botswana in 2004 to that in 2008?
Give a very brief answer. 0.85. What is the ratio of the Emissions(in percent) in Hungary in 2004 to that in 2008?
Your answer should be compact. 0.88. What is the ratio of the Emissions(in percent) in Angola in 2004 to that in 2009?
Provide a short and direct response. 0.57. What is the ratio of the Emissions(in percent) of Botswana in 2004 to that in 2009?
Your answer should be very brief. 0.79. What is the ratio of the Emissions(in percent) in Hungary in 2004 to that in 2009?
Offer a very short reply. 0.81. What is the ratio of the Emissions(in percent) of South Asia in 2004 to that in 2010?
Your answer should be compact. 1.06. What is the ratio of the Emissions(in percent) in Angola in 2004 to that in 2010?
Provide a short and direct response. 0.57. What is the ratio of the Emissions(in percent) of Botswana in 2004 to that in 2010?
Make the answer very short. 0.88. What is the ratio of the Emissions(in percent) in Hungary in 2004 to that in 2010?
Give a very brief answer. 0.86. What is the ratio of the Emissions(in percent) in South Asia in 2004 to that in 2011?
Offer a very short reply. 1.11. What is the ratio of the Emissions(in percent) in Angola in 2004 to that in 2011?
Your answer should be very brief. 0.58. What is the ratio of the Emissions(in percent) in Botswana in 2004 to that in 2011?
Your answer should be compact. 0.77. What is the ratio of the Emissions(in percent) in Hungary in 2004 to that in 2011?
Offer a very short reply. 0.9. What is the ratio of the Emissions(in percent) of Angola in 2005 to that in 2006?
Offer a terse response. 0.71. What is the ratio of the Emissions(in percent) of Botswana in 2005 to that in 2006?
Provide a succinct answer. 0.96. What is the ratio of the Emissions(in percent) in Hungary in 2005 to that in 2006?
Provide a short and direct response. 0.96. What is the ratio of the Emissions(in percent) in South Asia in 2005 to that in 2007?
Offer a terse response. 1.05. What is the ratio of the Emissions(in percent) of Angola in 2005 to that in 2007?
Give a very brief answer. 0.71. What is the ratio of the Emissions(in percent) of Botswana in 2005 to that in 2007?
Offer a terse response. 0.87. What is the ratio of the Emissions(in percent) in Hungary in 2005 to that in 2007?
Ensure brevity in your answer.  0.93. What is the ratio of the Emissions(in percent) in South Asia in 2005 to that in 2008?
Give a very brief answer. 0.98. What is the ratio of the Emissions(in percent) of Angola in 2005 to that in 2008?
Offer a very short reply. 0.57. What is the ratio of the Emissions(in percent) in Botswana in 2005 to that in 2008?
Offer a very short reply. 0.83. What is the ratio of the Emissions(in percent) of Hungary in 2005 to that in 2008?
Provide a succinct answer. 0.94. What is the ratio of the Emissions(in percent) of South Asia in 2005 to that in 2009?
Your answer should be compact. 0.96. What is the ratio of the Emissions(in percent) in Angola in 2005 to that in 2009?
Give a very brief answer. 0.52. What is the ratio of the Emissions(in percent) of Botswana in 2005 to that in 2009?
Provide a short and direct response. 0.77. What is the ratio of the Emissions(in percent) of Hungary in 2005 to that in 2009?
Give a very brief answer. 0.87. What is the ratio of the Emissions(in percent) in South Asia in 2005 to that in 2010?
Your answer should be very brief. 1.02. What is the ratio of the Emissions(in percent) of Angola in 2005 to that in 2010?
Provide a short and direct response. 0.52. What is the ratio of the Emissions(in percent) in Botswana in 2005 to that in 2010?
Offer a terse response. 0.85. What is the ratio of the Emissions(in percent) in Hungary in 2005 to that in 2010?
Give a very brief answer. 0.92. What is the ratio of the Emissions(in percent) of South Asia in 2005 to that in 2011?
Your answer should be compact. 1.07. What is the ratio of the Emissions(in percent) of Angola in 2005 to that in 2011?
Your answer should be very brief. 0.54. What is the ratio of the Emissions(in percent) in Botswana in 2005 to that in 2011?
Give a very brief answer. 0.75. What is the ratio of the Emissions(in percent) of Hungary in 2005 to that in 2011?
Offer a terse response. 0.96. What is the ratio of the Emissions(in percent) in South Asia in 2006 to that in 2007?
Provide a succinct answer. 1.06. What is the ratio of the Emissions(in percent) of Botswana in 2006 to that in 2007?
Your answer should be compact. 0.9. What is the ratio of the Emissions(in percent) of Hungary in 2006 to that in 2007?
Make the answer very short. 0.97. What is the ratio of the Emissions(in percent) of South Asia in 2006 to that in 2008?
Keep it short and to the point. 0.98. What is the ratio of the Emissions(in percent) of Angola in 2006 to that in 2008?
Your answer should be compact. 0.81. What is the ratio of the Emissions(in percent) of Botswana in 2006 to that in 2008?
Ensure brevity in your answer.  0.86. What is the ratio of the Emissions(in percent) of Hungary in 2006 to that in 2008?
Keep it short and to the point. 0.98. What is the ratio of the Emissions(in percent) in Angola in 2006 to that in 2009?
Offer a very short reply. 0.74. What is the ratio of the Emissions(in percent) in Botswana in 2006 to that in 2009?
Make the answer very short. 0.8. What is the ratio of the Emissions(in percent) in Hungary in 2006 to that in 2009?
Your answer should be very brief. 0.9. What is the ratio of the Emissions(in percent) of South Asia in 2006 to that in 2010?
Provide a succinct answer. 1.03. What is the ratio of the Emissions(in percent) of Angola in 2006 to that in 2010?
Your answer should be very brief. 0.74. What is the ratio of the Emissions(in percent) of Botswana in 2006 to that in 2010?
Your answer should be compact. 0.89. What is the ratio of the Emissions(in percent) in Hungary in 2006 to that in 2010?
Your answer should be compact. 0.96. What is the ratio of the Emissions(in percent) of South Asia in 2006 to that in 2011?
Your answer should be very brief. 1.08. What is the ratio of the Emissions(in percent) of Angola in 2006 to that in 2011?
Offer a very short reply. 0.75. What is the ratio of the Emissions(in percent) in Botswana in 2006 to that in 2011?
Offer a very short reply. 0.78. What is the ratio of the Emissions(in percent) in South Asia in 2007 to that in 2008?
Your response must be concise. 0.93. What is the ratio of the Emissions(in percent) of Angola in 2007 to that in 2008?
Provide a short and direct response. 0.81. What is the ratio of the Emissions(in percent) in Botswana in 2007 to that in 2008?
Provide a succinct answer. 0.95. What is the ratio of the Emissions(in percent) in Hungary in 2007 to that in 2008?
Your response must be concise. 1.01. What is the ratio of the Emissions(in percent) in South Asia in 2007 to that in 2009?
Your response must be concise. 0.92. What is the ratio of the Emissions(in percent) in Angola in 2007 to that in 2009?
Provide a succinct answer. 0.74. What is the ratio of the Emissions(in percent) of Botswana in 2007 to that in 2009?
Provide a short and direct response. 0.89. What is the ratio of the Emissions(in percent) of Hungary in 2007 to that in 2009?
Give a very brief answer. 0.93. What is the ratio of the Emissions(in percent) of South Asia in 2007 to that in 2010?
Your response must be concise. 0.97. What is the ratio of the Emissions(in percent) of Angola in 2007 to that in 2010?
Give a very brief answer. 0.74. What is the ratio of the Emissions(in percent) in Botswana in 2007 to that in 2010?
Your answer should be very brief. 0.98. What is the ratio of the Emissions(in percent) in Hungary in 2007 to that in 2010?
Your answer should be very brief. 0.99. What is the ratio of the Emissions(in percent) in South Asia in 2007 to that in 2011?
Ensure brevity in your answer.  1.02. What is the ratio of the Emissions(in percent) in Angola in 2007 to that in 2011?
Provide a short and direct response. 0.76. What is the ratio of the Emissions(in percent) in Botswana in 2007 to that in 2011?
Provide a succinct answer. 0.86. What is the ratio of the Emissions(in percent) of Hungary in 2007 to that in 2011?
Offer a very short reply. 1.03. What is the ratio of the Emissions(in percent) in South Asia in 2008 to that in 2009?
Give a very brief answer. 0.98. What is the ratio of the Emissions(in percent) in Angola in 2008 to that in 2009?
Keep it short and to the point. 0.91. What is the ratio of the Emissions(in percent) in Botswana in 2008 to that in 2009?
Ensure brevity in your answer.  0.93. What is the ratio of the Emissions(in percent) of Hungary in 2008 to that in 2009?
Keep it short and to the point. 0.92. What is the ratio of the Emissions(in percent) of South Asia in 2008 to that in 2010?
Your answer should be compact. 1.04. What is the ratio of the Emissions(in percent) of Angola in 2008 to that in 2010?
Provide a succinct answer. 0.91. What is the ratio of the Emissions(in percent) of Botswana in 2008 to that in 2010?
Your answer should be very brief. 1.03. What is the ratio of the Emissions(in percent) in Hungary in 2008 to that in 2010?
Give a very brief answer. 0.98. What is the ratio of the Emissions(in percent) of South Asia in 2008 to that in 2011?
Your response must be concise. 1.09. What is the ratio of the Emissions(in percent) of Botswana in 2008 to that in 2011?
Your answer should be very brief. 0.9. What is the ratio of the Emissions(in percent) in Hungary in 2008 to that in 2011?
Give a very brief answer. 1.02. What is the ratio of the Emissions(in percent) of South Asia in 2009 to that in 2010?
Your response must be concise. 1.06. What is the ratio of the Emissions(in percent) of Angola in 2009 to that in 2010?
Make the answer very short. 1. What is the ratio of the Emissions(in percent) in Botswana in 2009 to that in 2010?
Your answer should be very brief. 1.11. What is the ratio of the Emissions(in percent) of Hungary in 2009 to that in 2010?
Give a very brief answer. 1.06. What is the ratio of the Emissions(in percent) in South Asia in 2009 to that in 2011?
Keep it short and to the point. 1.11. What is the ratio of the Emissions(in percent) of Angola in 2009 to that in 2011?
Offer a terse response. 1.02. What is the ratio of the Emissions(in percent) in Botswana in 2009 to that in 2011?
Your response must be concise. 0.97. What is the ratio of the Emissions(in percent) of Hungary in 2009 to that in 2011?
Provide a short and direct response. 1.11. What is the ratio of the Emissions(in percent) in South Asia in 2010 to that in 2011?
Provide a succinct answer. 1.05. What is the ratio of the Emissions(in percent) in Angola in 2010 to that in 2011?
Give a very brief answer. 1.02. What is the ratio of the Emissions(in percent) in Botswana in 2010 to that in 2011?
Ensure brevity in your answer.  0.88. What is the ratio of the Emissions(in percent) in Hungary in 2010 to that in 2011?
Offer a terse response. 1.05. What is the difference between the highest and the second highest Emissions(in percent) in South Asia?
Offer a very short reply. 0.07. What is the difference between the highest and the second highest Emissions(in percent) in Angola?
Ensure brevity in your answer.  0.05. What is the difference between the highest and the second highest Emissions(in percent) in Botswana?
Provide a short and direct response. 1.48. What is the difference between the highest and the second highest Emissions(in percent) in Hungary?
Offer a terse response. 1.9. What is the difference between the highest and the lowest Emissions(in percent) in South Asia?
Ensure brevity in your answer.  2.45. What is the difference between the highest and the lowest Emissions(in percent) of Angola?
Provide a short and direct response. 22.57. What is the difference between the highest and the lowest Emissions(in percent) in Botswana?
Offer a terse response. 14.31. What is the difference between the highest and the lowest Emissions(in percent) of Hungary?
Your answer should be compact. 6.19. 